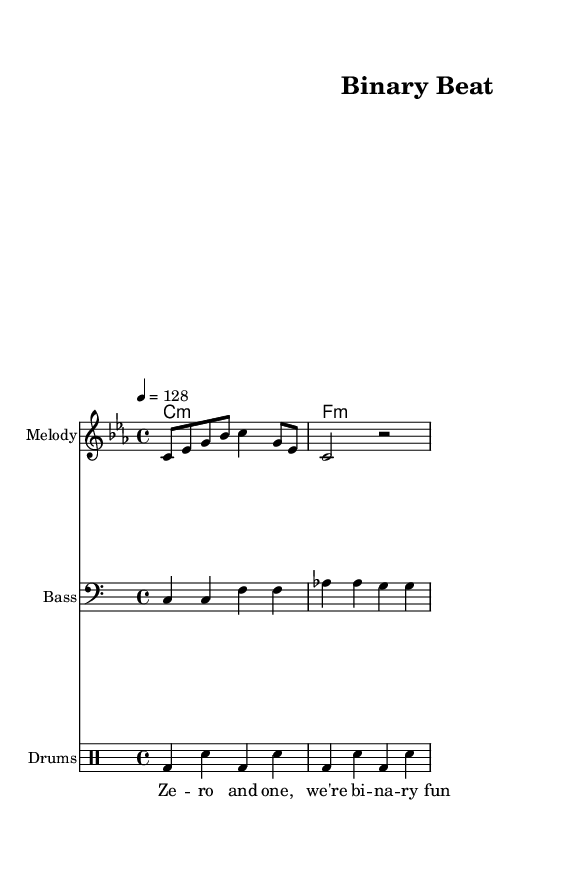What is the key signature of this music? The key signature is C minor, which contains three flats (B, E, A). This can be identified by looking at the key signature section at the beginning of the sheet music.
Answer: C minor What is the time signature of the piece? The time signature is 4/4, which means there are four beats in each measure and a quarter note receives one beat. This is noted at the beginning of the score next to the clef.
Answer: 4/4 What is the tempo marking of this piece? The tempo marking indicates a speed of 128 beats per minute, which is provided in the tempo notation at the start of the piece, showing the value and the symbol.
Answer: 128 How many measures are in the melody section? The melody section consists of two measures, which can be determined by counting the music staff's divisions where the vertical lines (bar lines) are located.
Answer: 2 What type of chord is used at the start of the harmony section? The start of the harmony section features a C minor chord, indicated by the "c1:m" chord notation in the score, reflecting the progression of the chords used in this piece.
Answer: C minor What digital element is represented in the lyrics? The lyrics reference "binary," which reflects a key theme in electronic music often associated with digital sounds and technology, as illustrated in the lyric line that states "Zero and one, we're binary fun".
Answer: Binary What rhythmic pattern is used for the drums? The rhythmic pattern for the drums alternates beats between bass drum and snare drum consistently throughout two measures, demonstrated through the drumming notation where "bd" represents bass drum and "sn" represents snare drum.
Answer: Alternating 